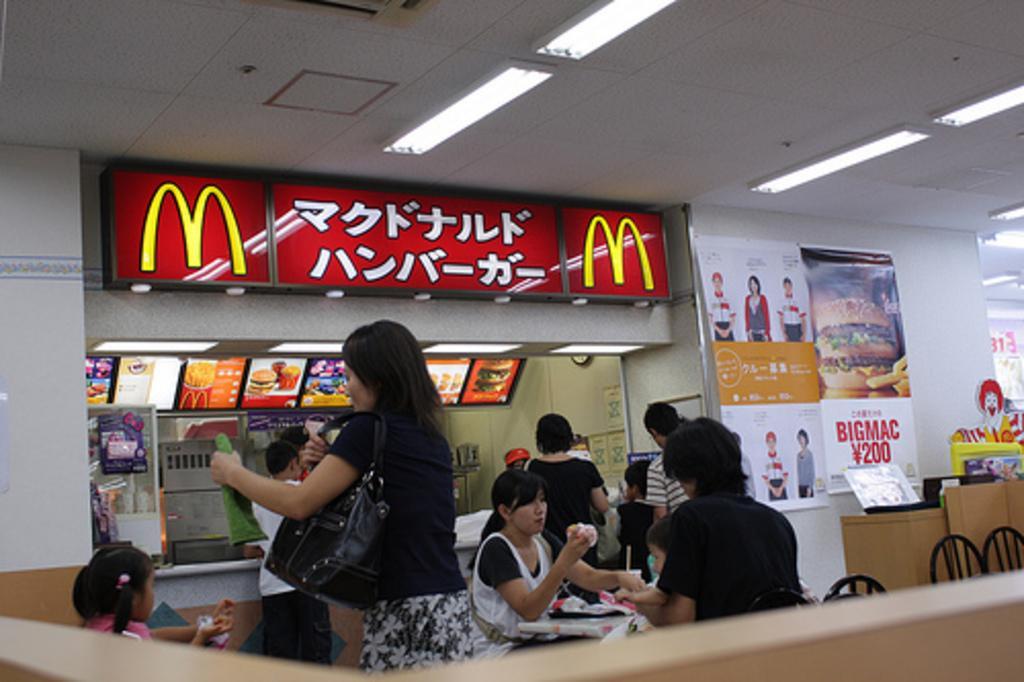Could you give a brief overview of what you see in this image? In this image, we can see people standing and sitting and some are holding snacks and there is a lady wearing a bag and holding an object. In the background, there are posters on the wall and we can see chairs, boxes, boards, stands and some objects on the table and we can see lights, at the top. 